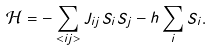Convert formula to latex. <formula><loc_0><loc_0><loc_500><loc_500>\mathcal { H } = - \sum _ { < i j > } J _ { i j } S _ { i } S _ { j } - h \sum _ { i } S _ { i } .</formula> 